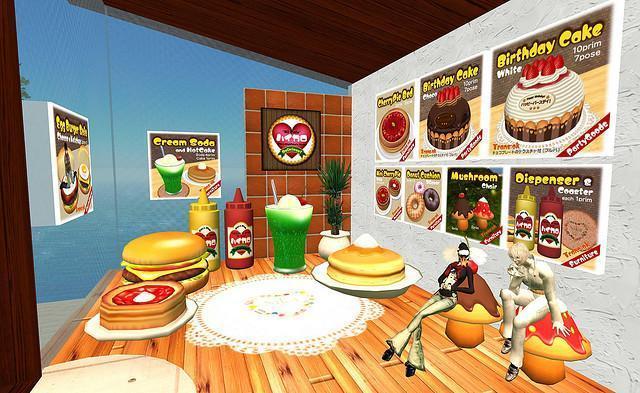How many cakes are visible?
Give a very brief answer. 4. How many cars are pictured?
Give a very brief answer. 0. 